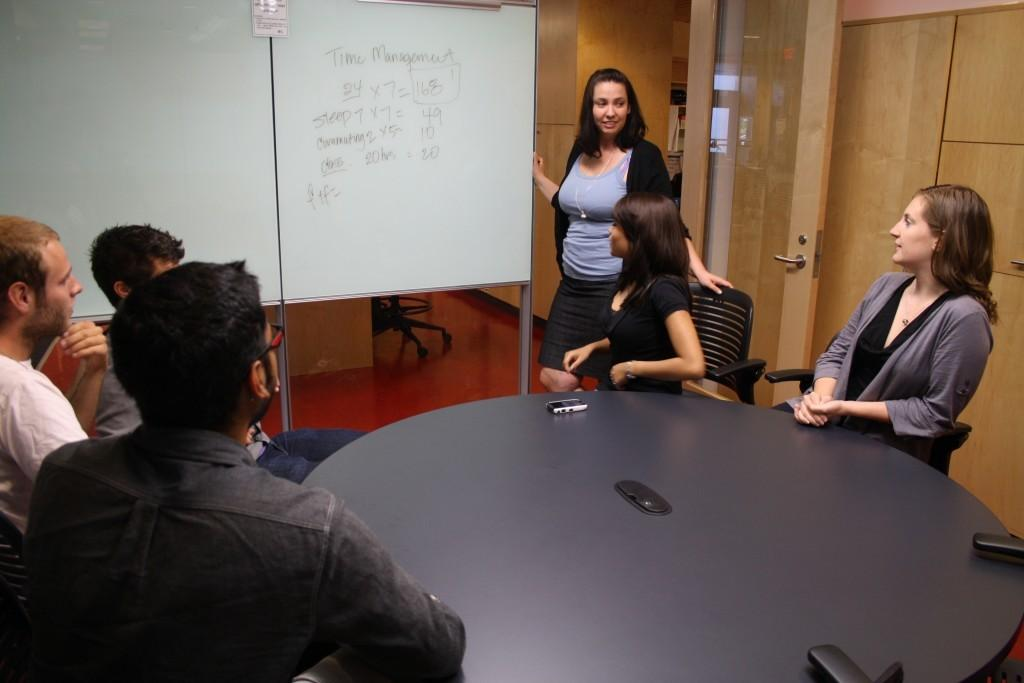What are the people in the image doing? The people in the image are sitting on chairs. Can you describe the woman in the image? There is a woman standing in the image. What type of match is the woman holding in the image? There is no match present in the image, and the woman is not holding anything. Where is the school located in the image? There is no school present in the image. 